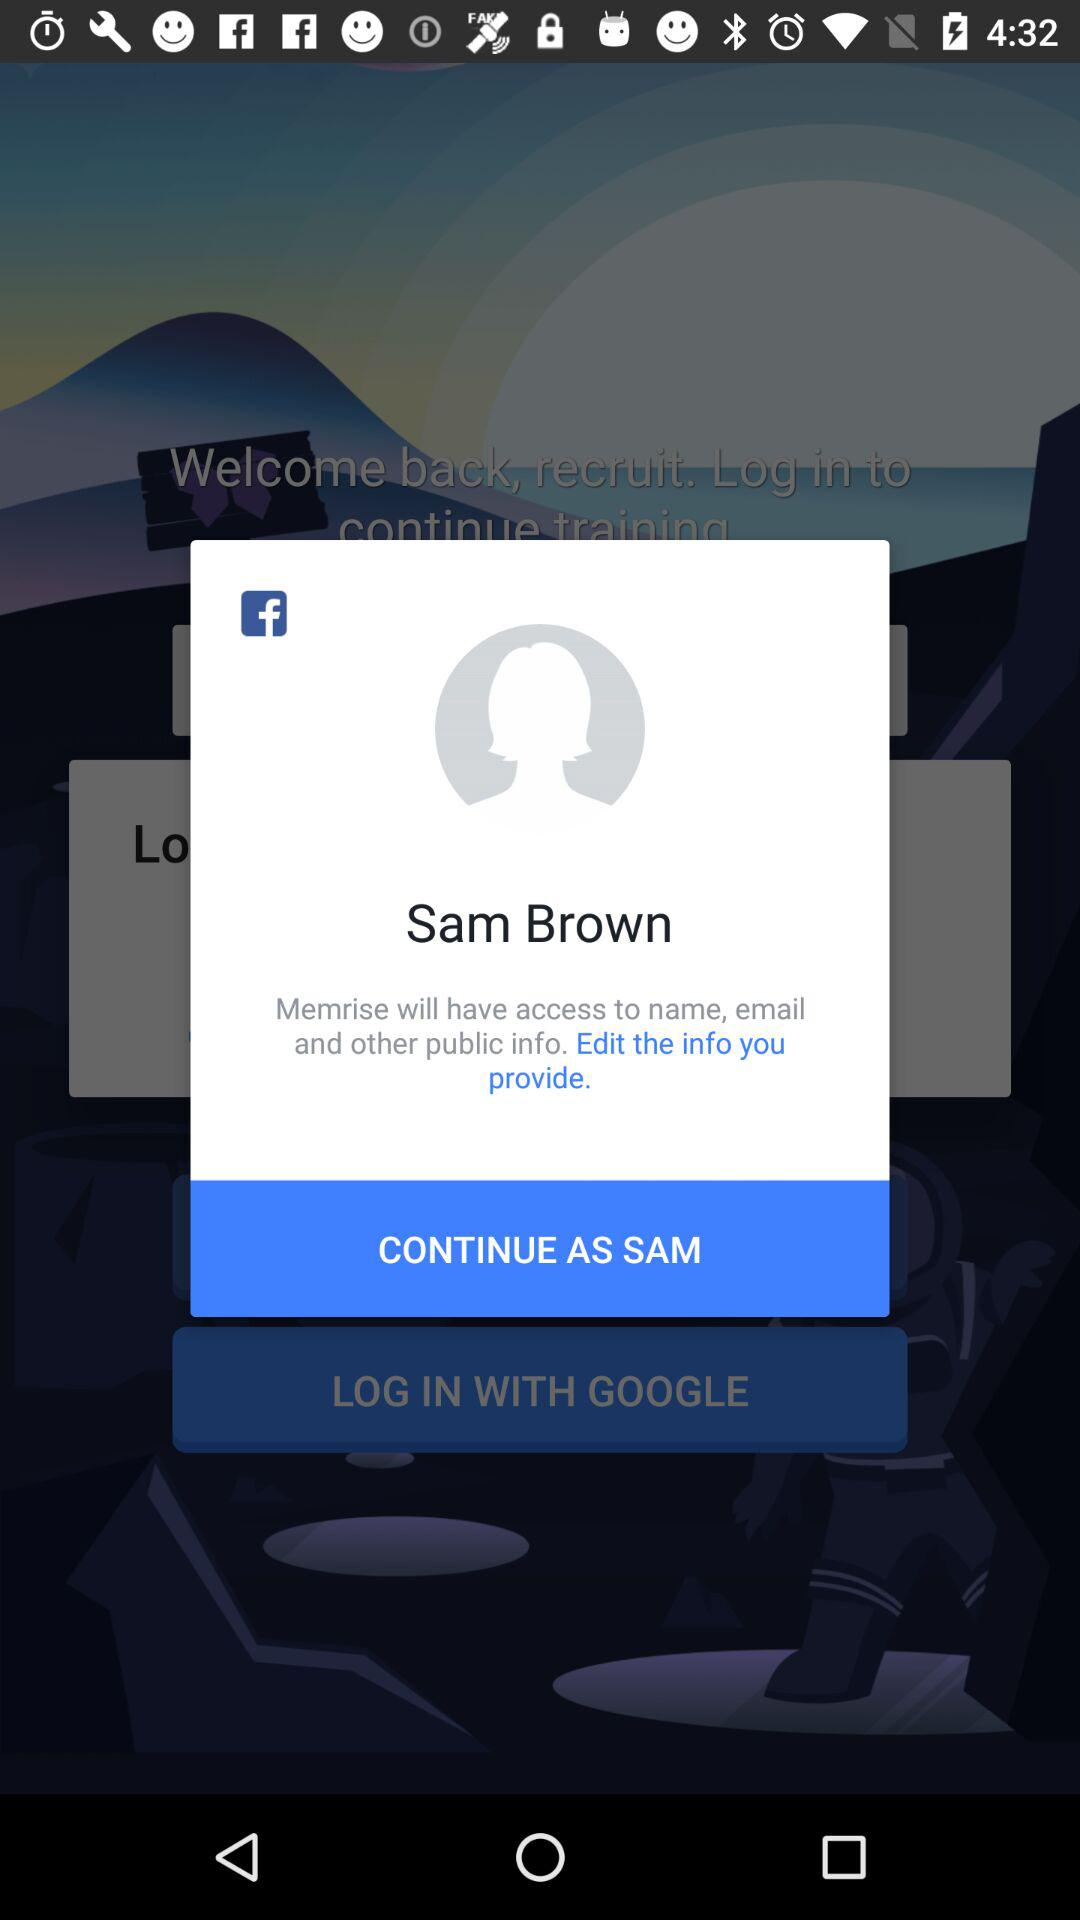What is the name of the user? The name of the user is Sam Brown. 